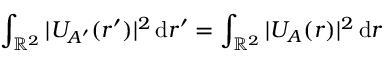Convert formula to latex. <formula><loc_0><loc_0><loc_500><loc_500>\int _ { { \mathbb { R } } ^ { 2 } } | U _ { A ^ { \prime } } ( \boldsymbol r ^ { \prime } ) | ^ { 2 } \, d \boldsymbol r ^ { \prime } = \int _ { { \mathbb { R } } ^ { 2 } } | U _ { A } ( \boldsymbol r ) | ^ { 2 } \, d \boldsymbol r</formula> 